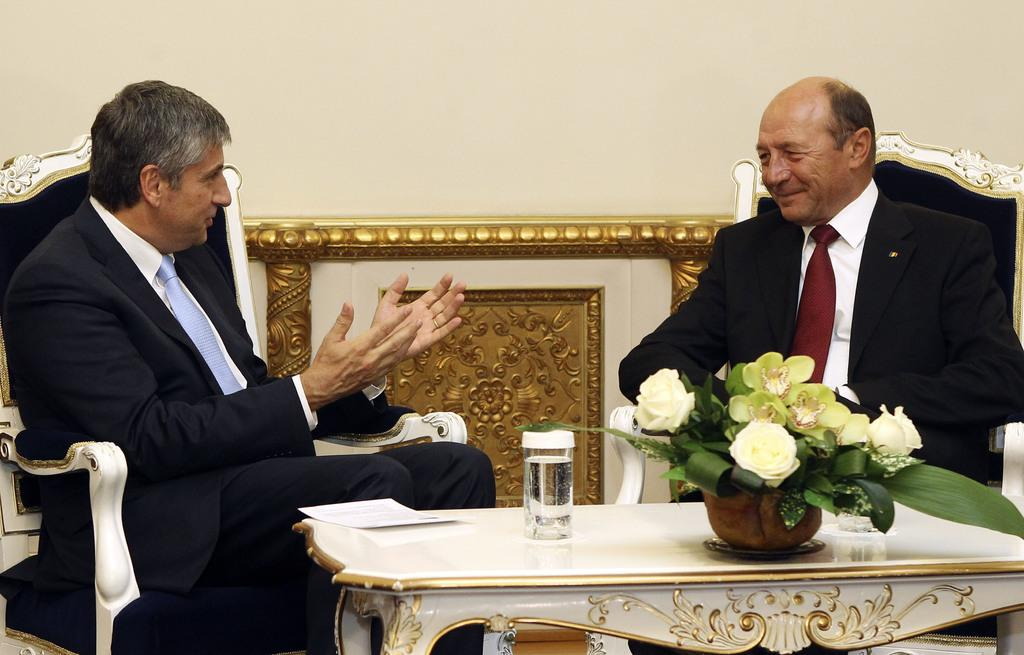How many people are present in the image? There are two men seated in the image. What are the men doing in the image? One man is speaking to the other. What can be seen on the table in the image? There is a flower pot and a glass of water on the table. What type of potato is being used as a chess piece in the image? There is no chess or potato present in the image. Can you describe the sand on the table in the image? There is no sand present in the image; the table only contains a flower pot and a glass of water. 